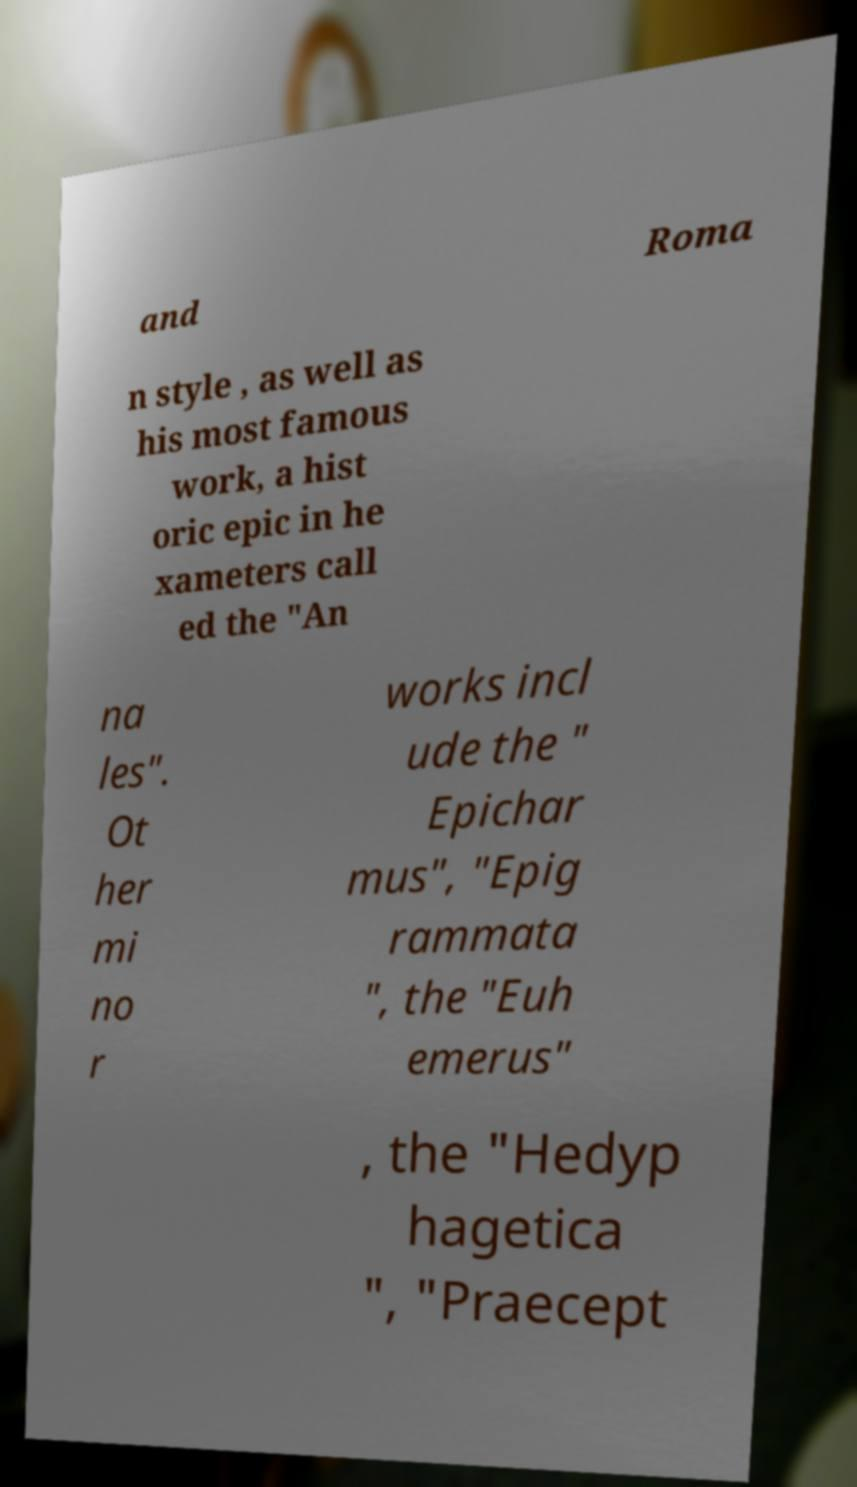There's text embedded in this image that I need extracted. Can you transcribe it verbatim? and Roma n style , as well as his most famous work, a hist oric epic in he xameters call ed the "An na les". Ot her mi no r works incl ude the " Epichar mus", "Epig rammata ", the "Euh emerus" , the "Hedyp hagetica ", "Praecept 